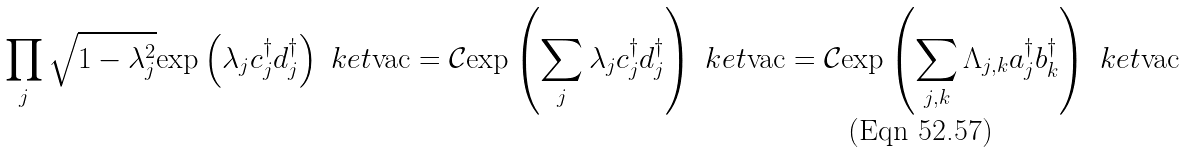<formula> <loc_0><loc_0><loc_500><loc_500>\prod _ { j } \sqrt { 1 - \lambda _ { j } ^ { 2 } } \text {exp} \left ( \lambda _ { j } c ^ { \dagger } _ { j } d ^ { \dagger } _ { j } \right ) \ k e t { \text {vac} } = \mathcal { C } \text {exp} \left ( \sum _ { j } \lambda _ { j } c ^ { \dagger } _ { j } d ^ { \dagger } _ { j } \right ) \ k e t { \text {vac} } = \mathcal { C } \text {exp} \left ( \sum _ { j , k } \Lambda _ { j , k } a ^ { \dagger } _ { j } b ^ { \dagger } _ { k } \right ) \ k e t { \text {vac} }</formula> 